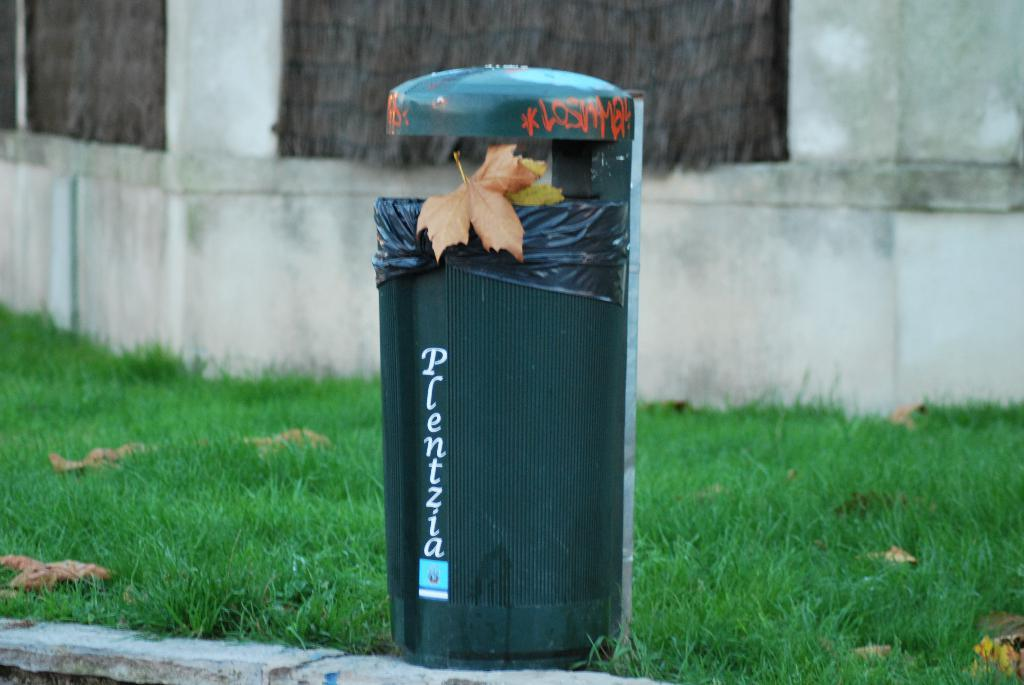What object can be seen in the image for disposing of waste? There is a dustbin in the image. What type of leaves can be seen in the image? There are brown and green color leaves in the image. What can be seen in the background of the image? There is a wall and green grass visible in the background of the image. Who is the manager of the representative seen in the image? There is no representative or manager present in the image; it only features a dustbin and leaves. 